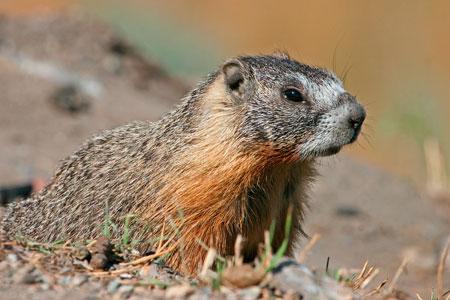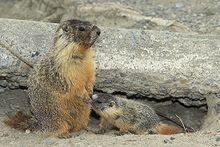The first image is the image on the left, the second image is the image on the right. Assess this claim about the two images: "One of the rodents is standing on its hind legs.". Correct or not? Answer yes or no. Yes. 